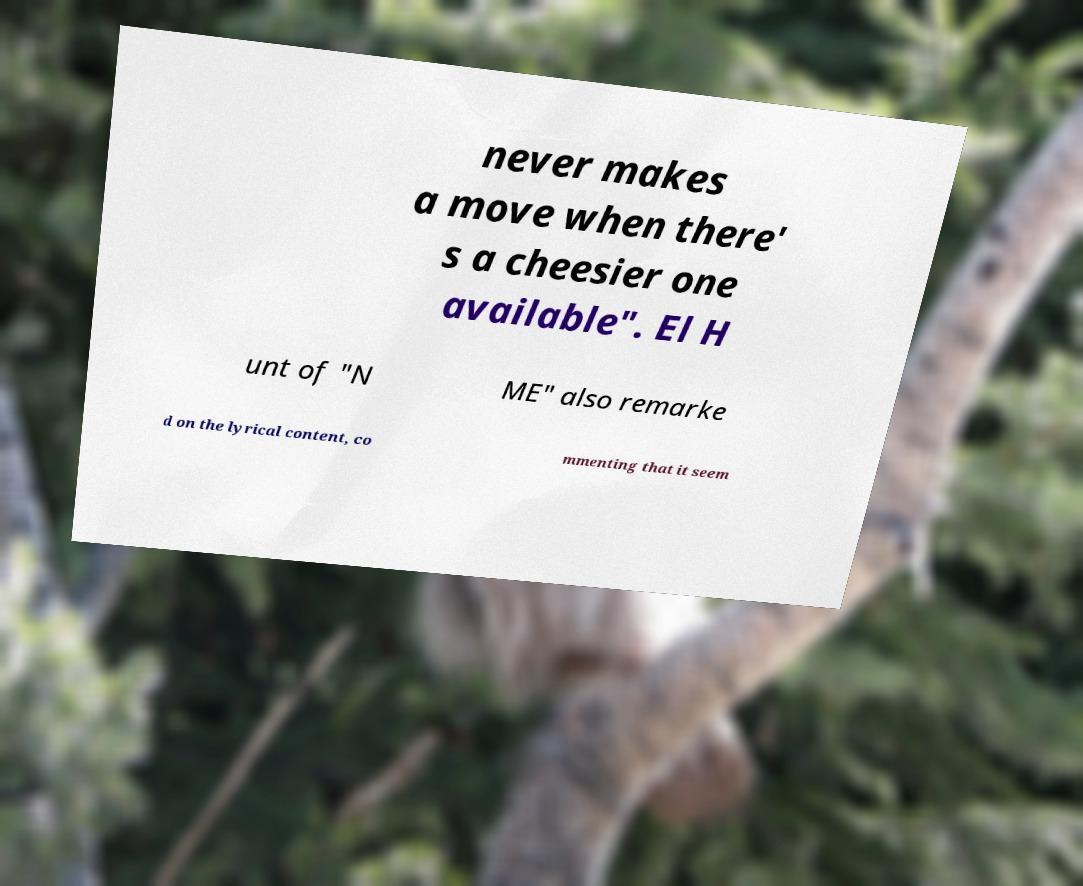What messages or text are displayed in this image? I need them in a readable, typed format. never makes a move when there' s a cheesier one available". El H unt of "N ME" also remarke d on the lyrical content, co mmenting that it seem 